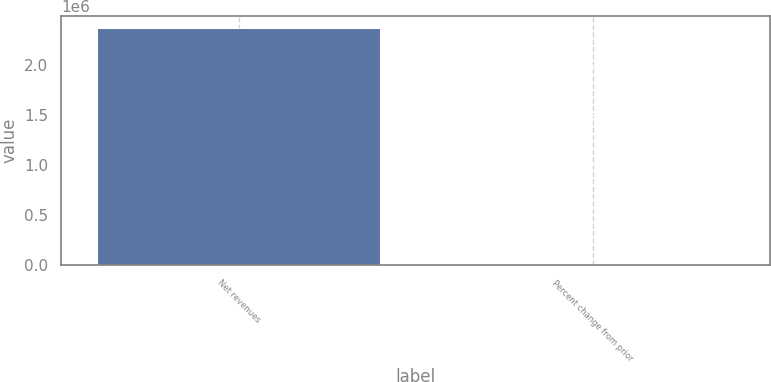Convert chart. <chart><loc_0><loc_0><loc_500><loc_500><bar_chart><fcel>Net revenues<fcel>Percent change from prior<nl><fcel>2.37093e+06<fcel>6<nl></chart> 